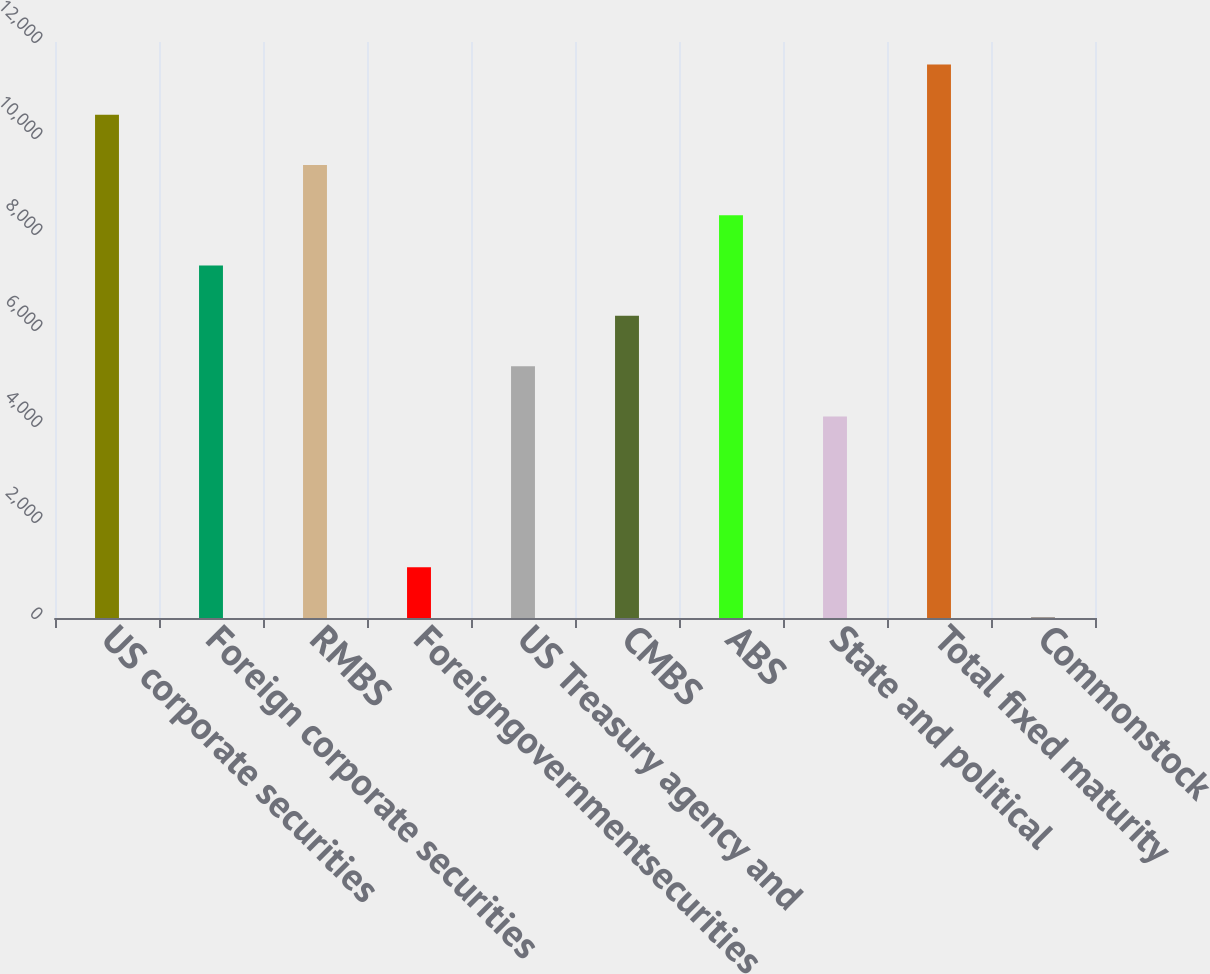<chart> <loc_0><loc_0><loc_500><loc_500><bar_chart><fcel>US corporate securities<fcel>Foreign corporate securities<fcel>RMBS<fcel>Foreigngovernmentsecurities<fcel>US Treasury agency and<fcel>CMBS<fcel>ABS<fcel>State and political<fcel>Total fixed maturity<fcel>Commonstock<nl><fcel>10486<fcel>7342.6<fcel>9438.2<fcel>1055.8<fcel>5247<fcel>6294.8<fcel>8390.4<fcel>4199.2<fcel>11533.8<fcel>8<nl></chart> 